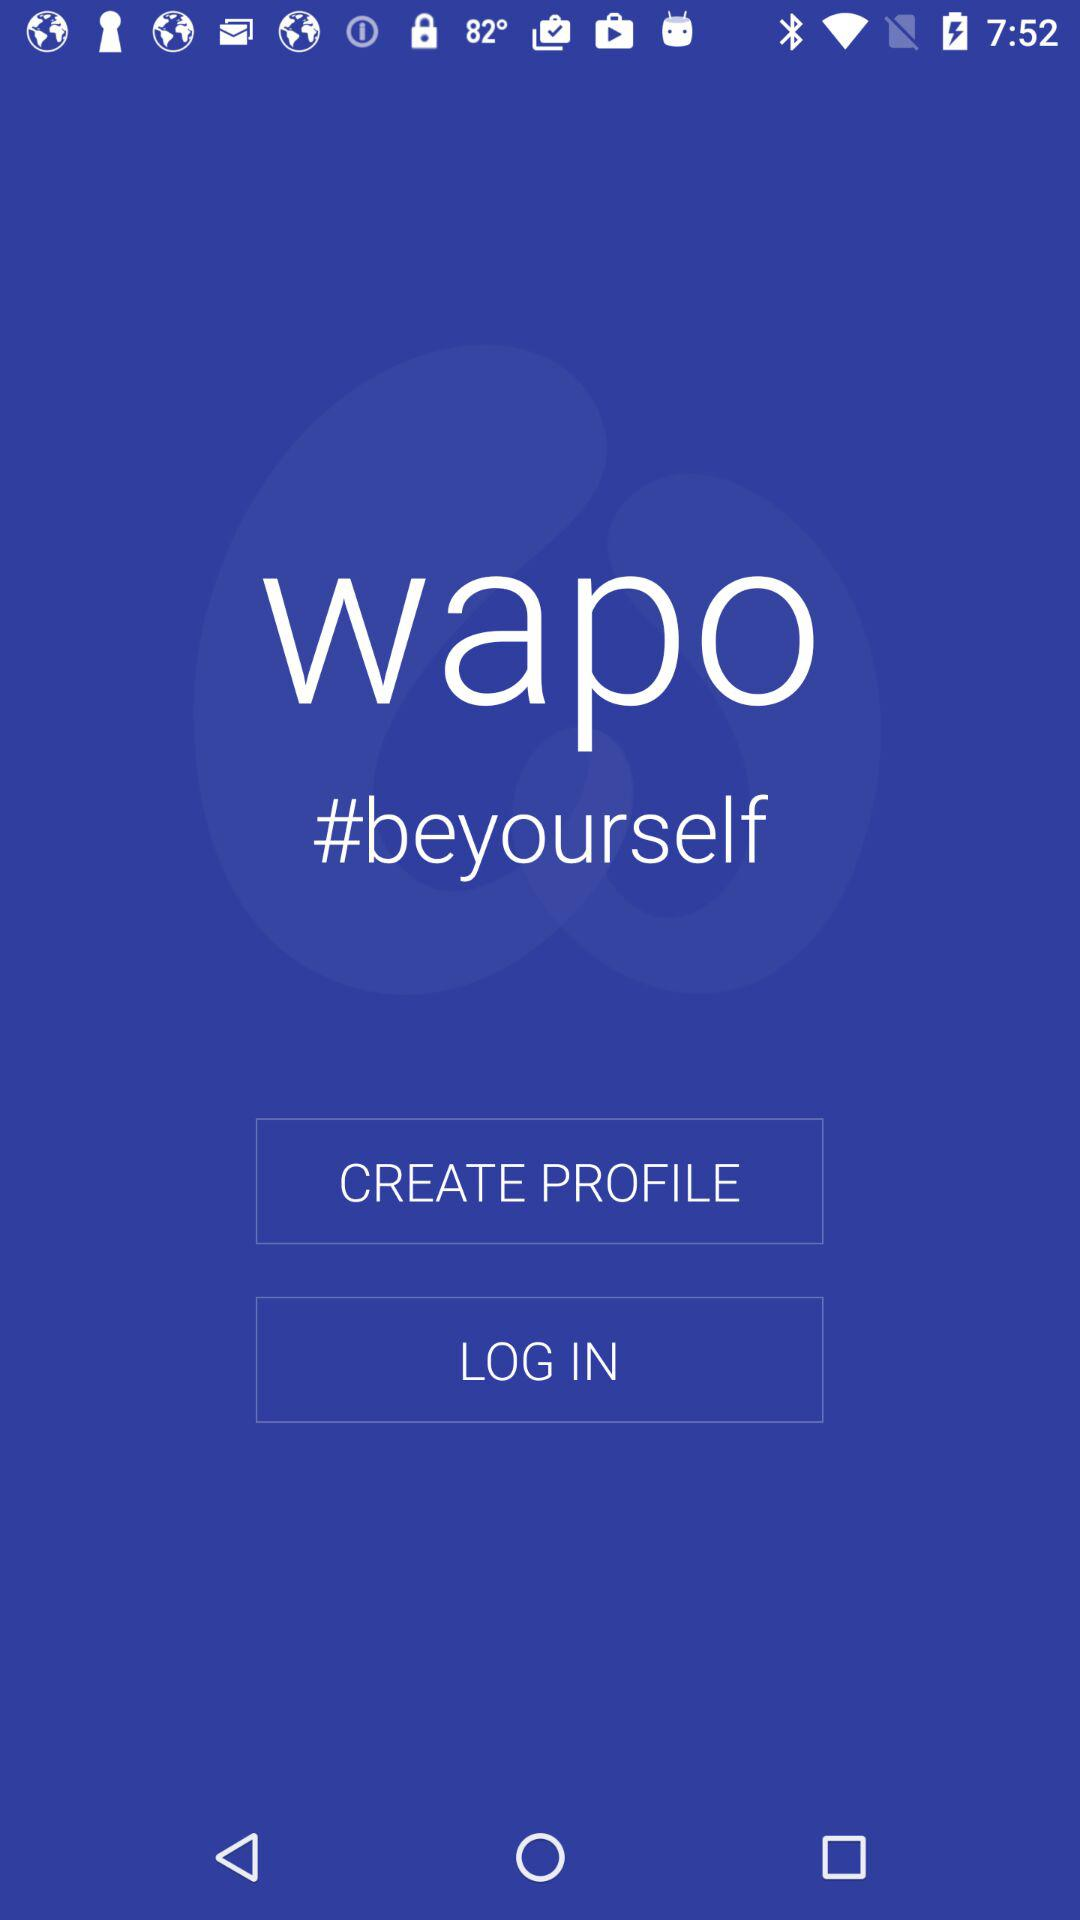What is the application name? The application name is "wapo". 